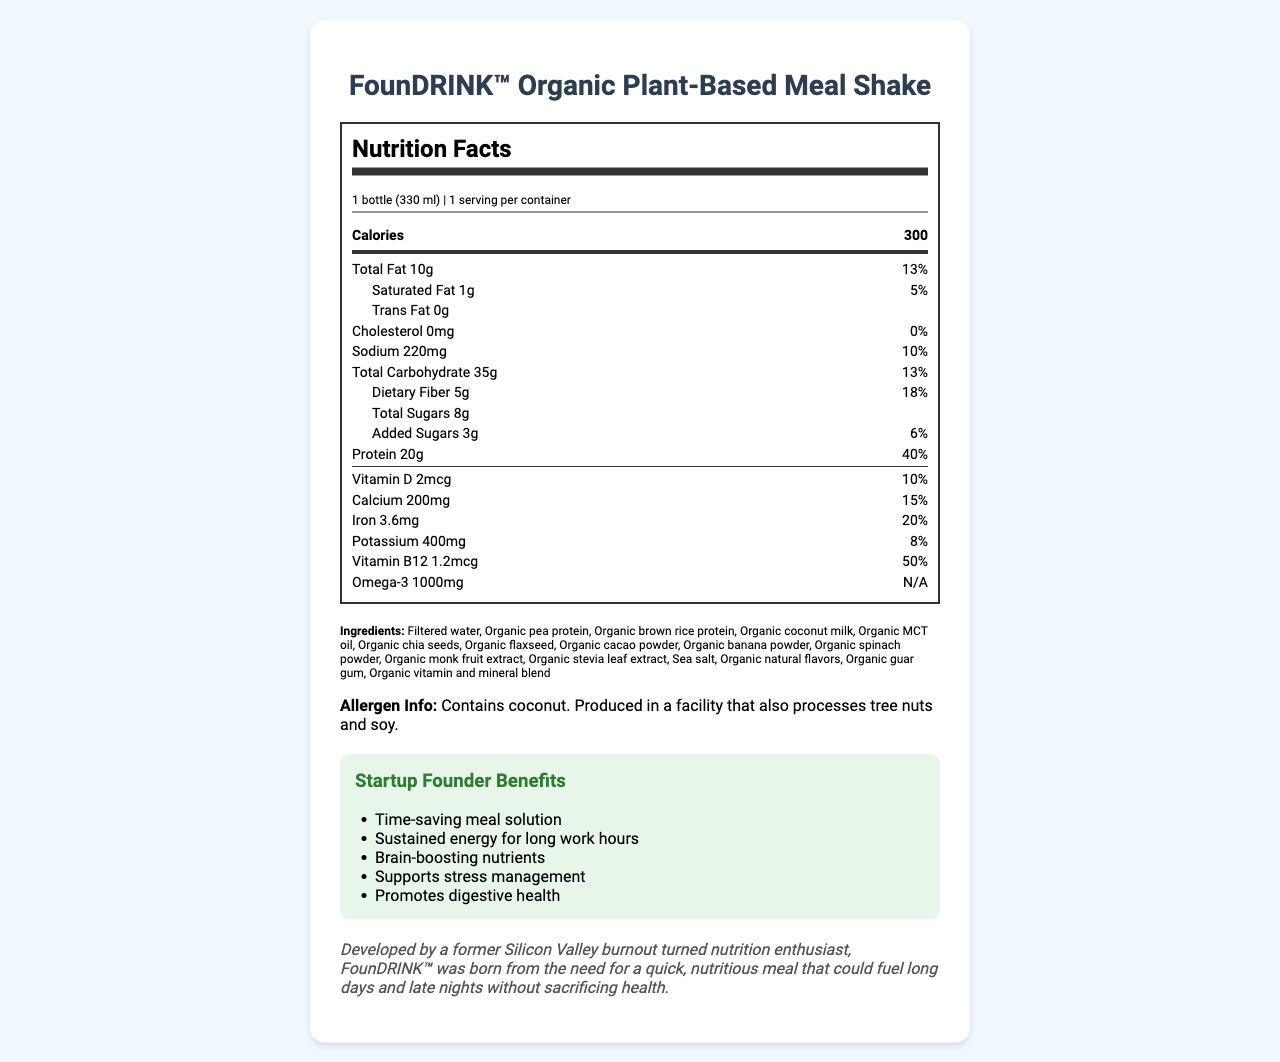what is the product name? The product name is displayed at the top of the document: "FounDRINK™ Organic Plant-Based Meal Shake".
Answer: FounDRINK™ Organic Plant-Based Meal Shake what is the serving size for one bottle? The serving size is stated in the serving information section: "1 bottle (330 ml)".
Answer: 1 bottle (330 ml) how many calories are in one serving? The calories are listed prominently in the nutrition label: "Calories 300".
Answer: 300 what is the total fat content in the shake? The total fat content is listed in the nutrition label: "Total Fat 10g".
Answer: 10g how much protein does one serving contain? The protein content is listed in the nutrition label: "Protein 20g".
Answer: 20g which ingredient is the primary source of omega-3 in the shake? Organic flaxseed is known for its omega-3 content and is listed in the ingredients.
Answer: Organic flaxseed does the shake contain any cholesterol? The nutrition label states "Cholesterol 0mg", indicating there is no cholesterol in the shake.
Answer: No what percentage of the daily value of calcium is provided by the shake? The nutrition label shows "Calcium 15%" indicating the percentage of daily value.
Answer: 15% who developed the FounDRINK™ shake? A. A professional athlete B. A former Silicon Valley burnout C. A celebrity chef D. A medical doctor The document states that the shake was developed by "a former Silicon Valley burnout turned nutrition enthusiast".
Answer: B how many grams of added sugars are in the shake? A. 2g B. 3g C. 5g D. 8g The nutrition label states "Added Sugars 3g (6% DV)", so the correct answer is 3g.
Answer: B is the FounDRINK™ shake suitable for someone with nut allergies? The allergen information states that the shake contains coconut and is produced in a facility that also processes tree nuts and soy, which might be a concern for someone with nut allergies.
Answer: Not necessarily summarize the main idea of the document The main idea of the document is to present the comprehensive nutritional profile and benefits of the FounDRINK™ shake, emphasizing its suitability as a quick and healthy meal option for busy entrepreneurs.
Answer: The document provides the nutrition facts, ingredients, and benefits of the FounDRINK™ Organic Plant-Based Meal Shake, a nutritious meal replacement developed by a former Silicon Valley burnout for busy startup founders. It highlights the product's calorie content, macronutrients, vitamins, minerals, and key ingredients aimed at promoting energy, brain function, and stress management. how much vitamin B12 does one serving contain? The nutrition label states "Vitamin B12 1.2mcg (50% DV)", indicating the amount of Vitamin B12 per serving.
Answer: 1.2mcg are there any artificial flavors in the shake? The ingredients list includes "Organic natural flavors", implying that there are no artificial flavors.
Answer: No what are some of the benefits of the FounDRINK™ shake for startup founders? The benefits are explicitly listed under "Startup Founder Benefits": It mentions time-saving, sustained energy, brain-boosting, stress management support, and digestive health.
Answer: Time-saving meal solution, Sustained energy for long work hours, Brain-boosting nutrients, Supports stress management, Promotes digestive health is sea salt an ingredient in the FounDRINK™ shake? Sea salt is listed among the ingredients in the document.
Answer: Yes what is the total carbohydrate content in one bottle? The nutrition label lists "Total Carbohydrate 35g (13% DV)".
Answer: 35g from what facility-related condition might the shake contain tree nut or soy allergens? The allergen information states that the shake is produced in a facility that processes tree nuts and soy.
Answer: Produced in a facility that also processes tree nuts and soy. does the document specify the packaging type of the shake? The document does not provide any information regarding the packaging type.
Answer: I don't know how many servings are in one container? The serving information states "1 serving per container".
Answer: 1 